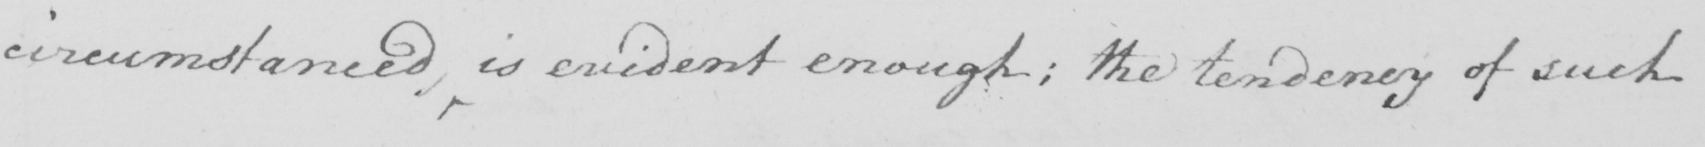What text is written in this handwritten line? circumstanced , is evident enough ; the tendency of such 